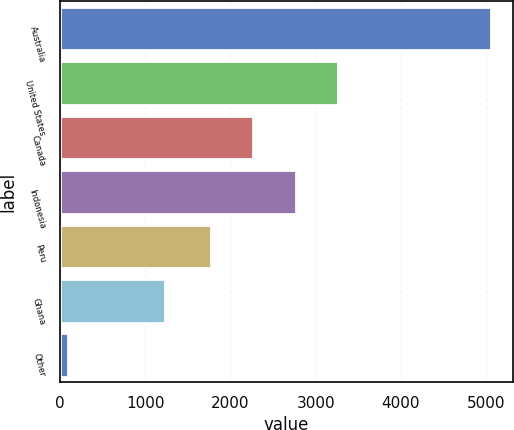Convert chart. <chart><loc_0><loc_0><loc_500><loc_500><bar_chart><fcel>Australia<fcel>United States<fcel>Canada<fcel>Indonesia<fcel>Peru<fcel>Ghana<fcel>Other<nl><fcel>5055<fcel>3260.3<fcel>2268.1<fcel>2764.2<fcel>1772<fcel>1231<fcel>94<nl></chart> 